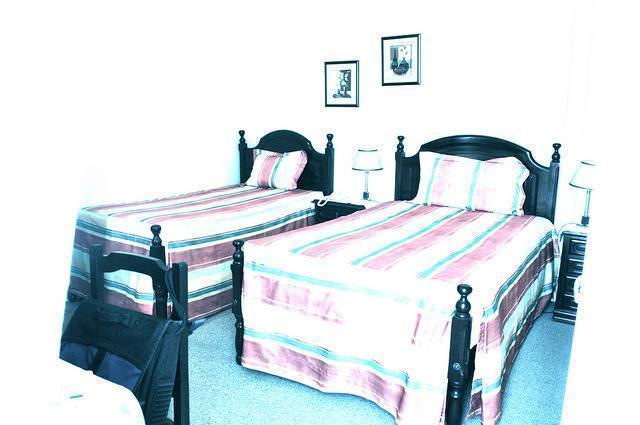How many people can sleep in this room?
Select the correct answer and articulate reasoning with the following format: 'Answer: answer
Rationale: rationale.'
Options: Six, four, two, eight. Answer: two.
Rationale: These are twin size beds that are used for one person each 